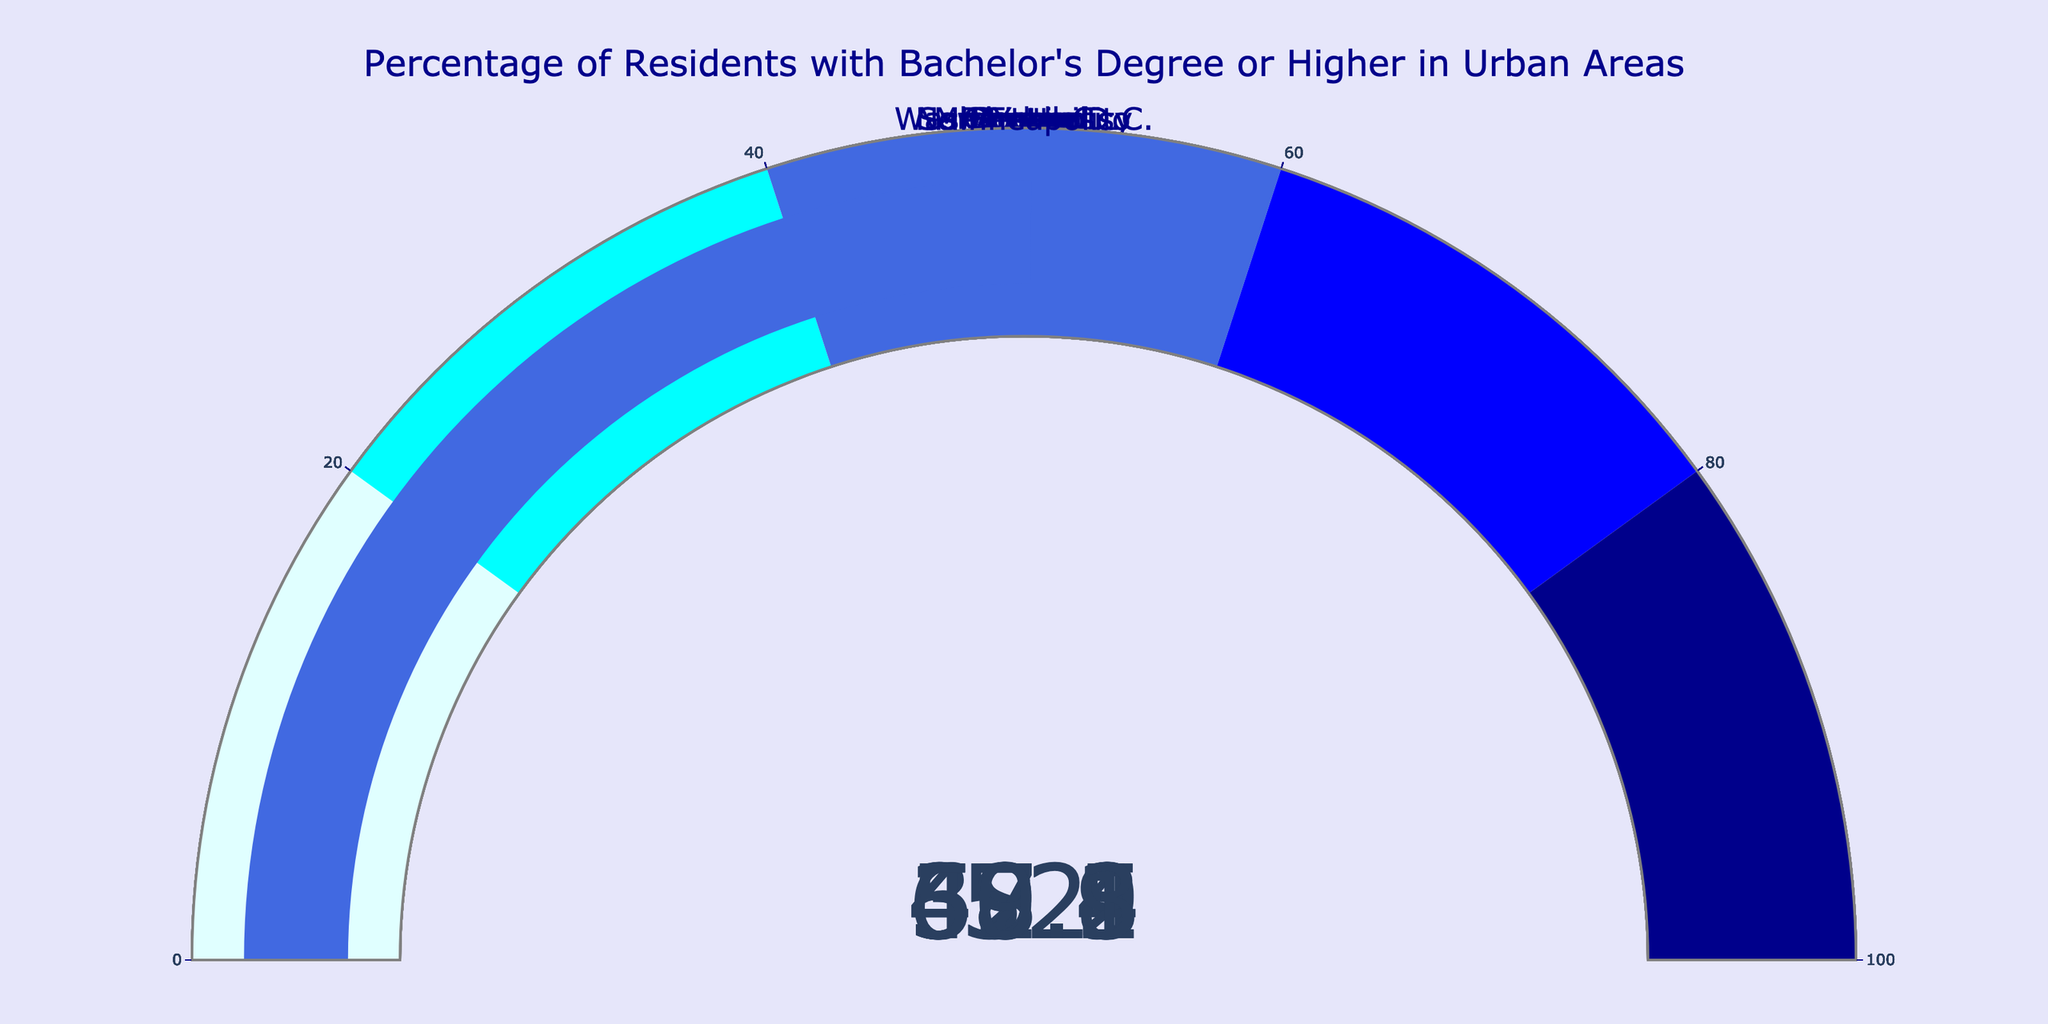What's the title of the figure? The title is displayed at the top of the figure and reads "Percentage of Residents with Bachelor's Degree or Higher in Urban Areas".
Answer: Percentage of Residents with Bachelor's Degree or Higher in Urban Areas Which city has the highest percentage of residents with a bachelor's degree or higher? The gauge for Seattle shows the highest value compared to other cities, which is at 62.8%.
Answer: Seattle How many cities have a percentage of residents with a bachelor's degree or higher that is above 50%? By examining each gauge, we see that there are 6 cities (San Francisco, Washington D.C., Austin, Denver, Minneapolis, and Seattle) with percentages above 50%.
Answer: 6 Are there any cities with a percentage lower than 40%? By looking at the gauges, New York City and Chicago have percentages below 40%, with 37.4% and 39.5%, respectively.
Answer: Yes Which city's percentage is closest to 50%? By examining the gauges, Denver has a percentage closest to 50%, with a value of 49.1%.
Answer: Denver What is the difference in the percentage of residents with a bachelor's degree or higher between San Francisco and Chicago? San Francisco shows 57.1% and Chicago shows 39.5%. The difference is 57.1% - 39.5% = 17.6%.
Answer: 17.6% Which city has a higher percentage of residents with a bachelor's degree or higher: Boston or Portland? Comparing gauges, Boston shows 48.2% and Portland shows 47.9%, so Boston has a higher percentage.
Answer: Boston What is the median value of the percentages across all listed cities? Arranging the percentages in ascending order (37.4, 39.5, 47.9, 48.2, 49.1, 50.3, 52.0, 57.1, 58.3, 62.8) and finding the middle value (average of 49.1 and 50.3) gives (49.1 + 50.3) / 2 = 49.7%.
Answer: 49.7% How many steps are represented in the gauge chart, and what are the color ranges? By observing the gauge chart, there are 5 steps, ranging from light cyan (0-20%), cyan (20-40%), royal blue (40-60%), blue (60-80%), and dark blue (80-100%).
Answer: 5 steps 